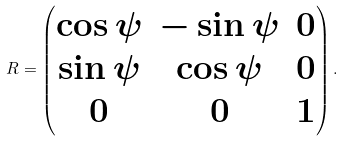Convert formula to latex. <formula><loc_0><loc_0><loc_500><loc_500>R = \begin{pmatrix} \cos \psi & - \sin \psi & 0 \\ \sin \psi & \cos \psi & 0 \\ 0 & 0 & 1 \end{pmatrix} .</formula> 